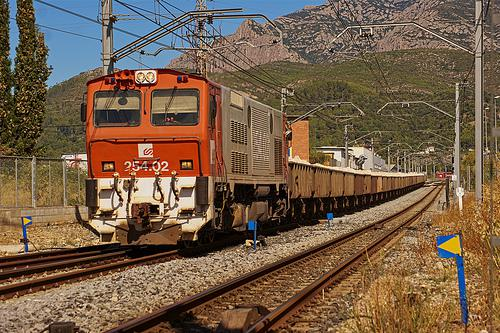Question: when was this picture taken?
Choices:
A. In the morning.
B. In the evening.
C. During the day.
D. At night.
Answer with the letter. Answer: C Question: where was this picture taken?
Choices:
A. At the bus stop.
B. At the airport.
C. In the parking lot.
D. Near the train track.
Answer with the letter. Answer: D Question: what type of vehicle is pictured?
Choices:
A. A train.
B. A bus.
C. A motorcycle.
D. A van.
Answer with the letter. Answer: A Question: how many dinosaurs are in the picture?
Choices:
A. 6.
B. 0.
C. 8.
D. 4.
Answer with the letter. Answer: B 